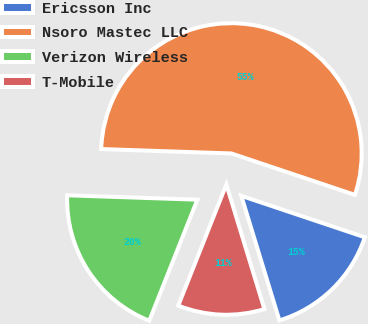<chart> <loc_0><loc_0><loc_500><loc_500><pie_chart><fcel>Ericsson Inc<fcel>Nsoro Mastec LLC<fcel>Verizon Wireless<fcel>T-Mobile<nl><fcel>15.13%<fcel>54.62%<fcel>19.52%<fcel>10.74%<nl></chart> 